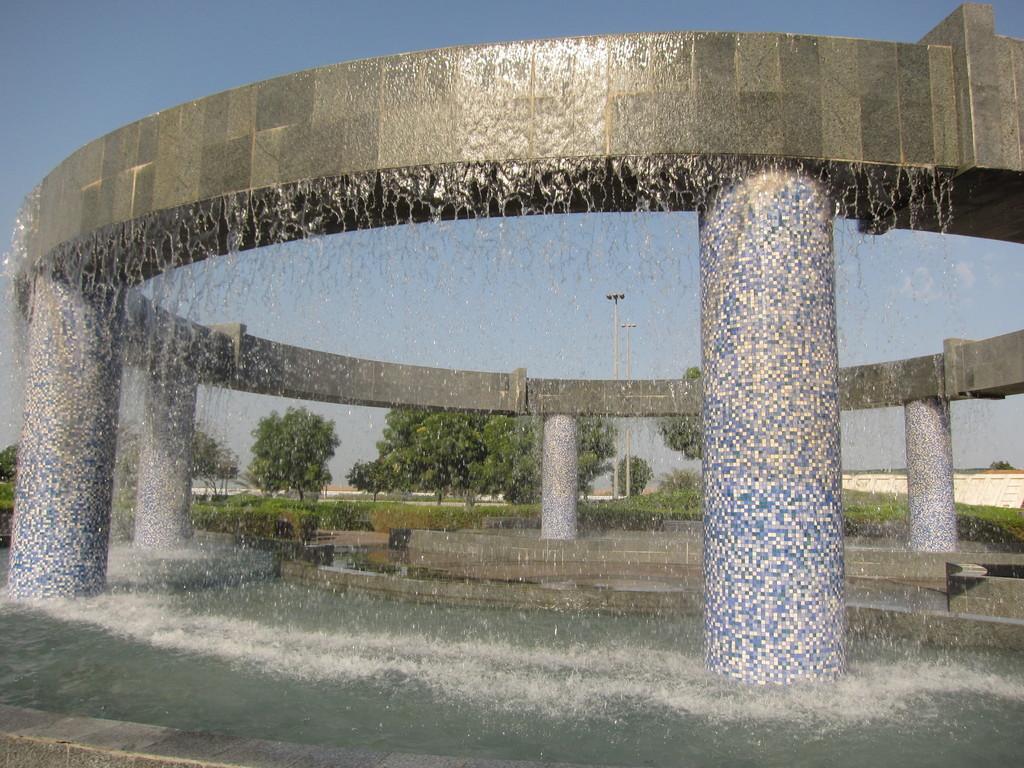Could you give a brief overview of what you see in this image? In the center of the image we can see water fountain. At the bottom we can see water. In the background there are trees and sky. 